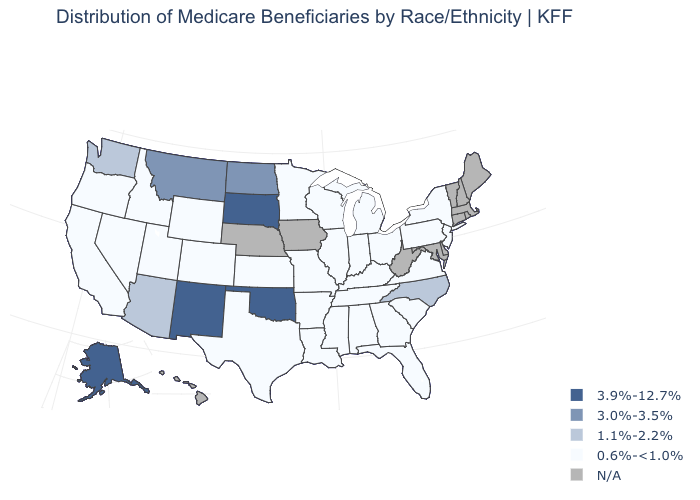What is the value of Maine?
Short answer required. N/A. What is the value of Arkansas?
Short answer required. 0.6%-<1.0%. Which states have the lowest value in the South?
Answer briefly. Alabama, Arkansas, Florida, Georgia, Kentucky, Louisiana, Mississippi, South Carolina, Tennessee, Texas, Virginia. Which states have the highest value in the USA?
Short answer required. Alaska, New Mexico, Oklahoma, South Dakota. Name the states that have a value in the range 1.1%-2.2%?
Answer briefly. Arizona, North Carolina, Washington. Which states have the lowest value in the USA?
Give a very brief answer. Alabama, Arkansas, California, Colorado, Florida, Georgia, Idaho, Illinois, Indiana, Kansas, Kentucky, Louisiana, Michigan, Minnesota, Mississippi, Missouri, Nevada, New Jersey, New York, Ohio, Oregon, Pennsylvania, South Carolina, Tennessee, Texas, Utah, Virginia, Wisconsin, Wyoming. Name the states that have a value in the range 0.6%-<1.0%?
Answer briefly. Alabama, Arkansas, California, Colorado, Florida, Georgia, Idaho, Illinois, Indiana, Kansas, Kentucky, Louisiana, Michigan, Minnesota, Mississippi, Missouri, Nevada, New Jersey, New York, Ohio, Oregon, Pennsylvania, South Carolina, Tennessee, Texas, Utah, Virginia, Wisconsin, Wyoming. Name the states that have a value in the range 0.6%-<1.0%?
Concise answer only. Alabama, Arkansas, California, Colorado, Florida, Georgia, Idaho, Illinois, Indiana, Kansas, Kentucky, Louisiana, Michigan, Minnesota, Mississippi, Missouri, Nevada, New Jersey, New York, Ohio, Oregon, Pennsylvania, South Carolina, Tennessee, Texas, Utah, Virginia, Wisconsin, Wyoming. How many symbols are there in the legend?
Quick response, please. 5. Among the states that border Nebraska , which have the highest value?
Give a very brief answer. South Dakota. Among the states that border Washington , which have the highest value?
Give a very brief answer. Idaho, Oregon. Which states have the lowest value in the USA?
Keep it brief. Alabama, Arkansas, California, Colorado, Florida, Georgia, Idaho, Illinois, Indiana, Kansas, Kentucky, Louisiana, Michigan, Minnesota, Mississippi, Missouri, Nevada, New Jersey, New York, Ohio, Oregon, Pennsylvania, South Carolina, Tennessee, Texas, Utah, Virginia, Wisconsin, Wyoming. Is the legend a continuous bar?
Keep it brief. No. Is the legend a continuous bar?
Short answer required. No. 